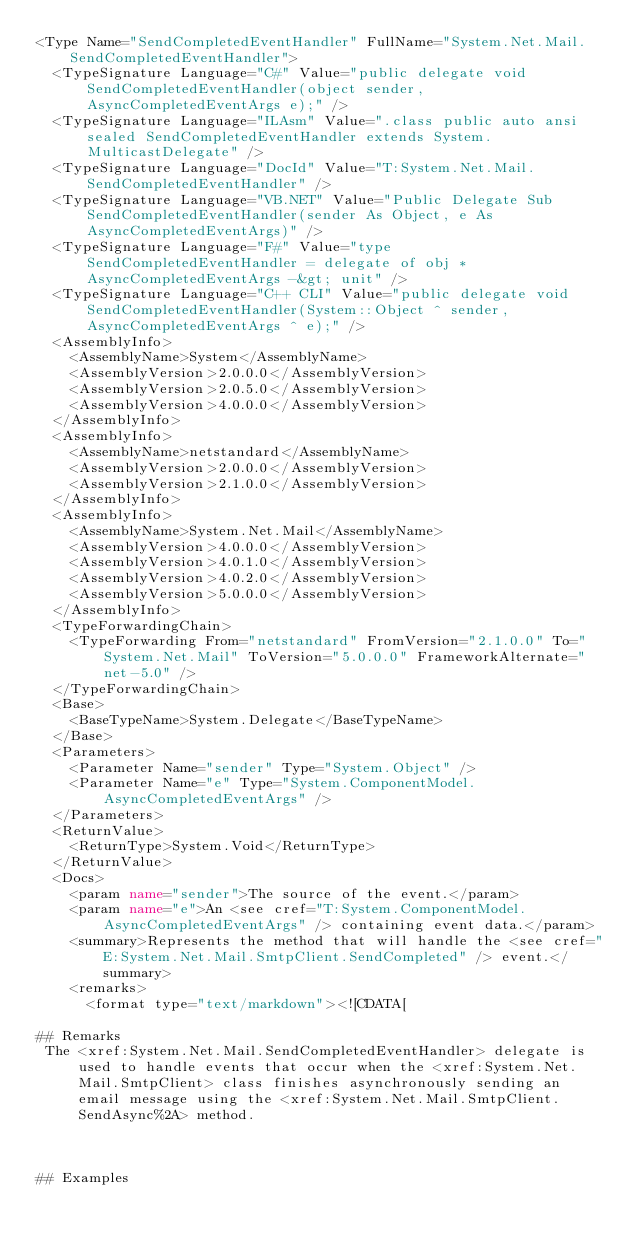<code> <loc_0><loc_0><loc_500><loc_500><_XML_><Type Name="SendCompletedEventHandler" FullName="System.Net.Mail.SendCompletedEventHandler">
  <TypeSignature Language="C#" Value="public delegate void SendCompletedEventHandler(object sender, AsyncCompletedEventArgs e);" />
  <TypeSignature Language="ILAsm" Value=".class public auto ansi sealed SendCompletedEventHandler extends System.MulticastDelegate" />
  <TypeSignature Language="DocId" Value="T:System.Net.Mail.SendCompletedEventHandler" />
  <TypeSignature Language="VB.NET" Value="Public Delegate Sub SendCompletedEventHandler(sender As Object, e As AsyncCompletedEventArgs)" />
  <TypeSignature Language="F#" Value="type SendCompletedEventHandler = delegate of obj * AsyncCompletedEventArgs -&gt; unit" />
  <TypeSignature Language="C++ CLI" Value="public delegate void SendCompletedEventHandler(System::Object ^ sender, AsyncCompletedEventArgs ^ e);" />
  <AssemblyInfo>
    <AssemblyName>System</AssemblyName>
    <AssemblyVersion>2.0.0.0</AssemblyVersion>
    <AssemblyVersion>2.0.5.0</AssemblyVersion>
    <AssemblyVersion>4.0.0.0</AssemblyVersion>
  </AssemblyInfo>
  <AssemblyInfo>
    <AssemblyName>netstandard</AssemblyName>
    <AssemblyVersion>2.0.0.0</AssemblyVersion>
    <AssemblyVersion>2.1.0.0</AssemblyVersion>
  </AssemblyInfo>
  <AssemblyInfo>
    <AssemblyName>System.Net.Mail</AssemblyName>
    <AssemblyVersion>4.0.0.0</AssemblyVersion>
    <AssemblyVersion>4.0.1.0</AssemblyVersion>
    <AssemblyVersion>4.0.2.0</AssemblyVersion>
    <AssemblyVersion>5.0.0.0</AssemblyVersion>
  </AssemblyInfo>
  <TypeForwardingChain>
    <TypeForwarding From="netstandard" FromVersion="2.1.0.0" To="System.Net.Mail" ToVersion="5.0.0.0" FrameworkAlternate="net-5.0" />
  </TypeForwardingChain>
  <Base>
    <BaseTypeName>System.Delegate</BaseTypeName>
  </Base>
  <Parameters>
    <Parameter Name="sender" Type="System.Object" />
    <Parameter Name="e" Type="System.ComponentModel.AsyncCompletedEventArgs" />
  </Parameters>
  <ReturnValue>
    <ReturnType>System.Void</ReturnType>
  </ReturnValue>
  <Docs>
    <param name="sender">The source of the event.</param>
    <param name="e">An <see cref="T:System.ComponentModel.AsyncCompletedEventArgs" /> containing event data.</param>
    <summary>Represents the method that will handle the <see cref="E:System.Net.Mail.SmtpClient.SendCompleted" /> event.</summary>
    <remarks>
      <format type="text/markdown"><![CDATA[  
  
## Remarks  
 The <xref:System.Net.Mail.SendCompletedEventHandler> delegate is used to handle events that occur when the <xref:System.Net.Mail.SmtpClient> class finishes asynchronously sending an email message using the <xref:System.Net.Mail.SmtpClient.SendAsync%2A> method.  
  
   
  
## Examples  </code> 